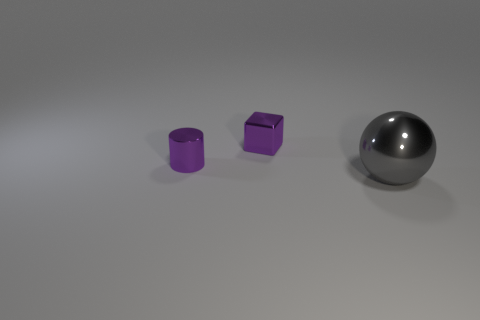Are there any large gray spheres made of the same material as the gray thing?
Your answer should be very brief. No. There is a purple thing that is the same size as the purple cube; what is its material?
Provide a succinct answer. Metal. There is a tiny metal thing in front of the cube; does it have the same color as the shiny object right of the purple shiny block?
Provide a short and direct response. No. There is a purple metallic object in front of the metal block; is there a tiny purple metal thing to the left of it?
Your answer should be compact. No. Does the object that is to the left of the shiny cube have the same shape as the tiny object that is behind the purple metal cylinder?
Your response must be concise. No. Do the small object in front of the small purple cube and the sphere that is in front of the purple shiny block have the same material?
Your answer should be very brief. Yes. The small purple object right of the purple thing in front of the cube is made of what material?
Provide a succinct answer. Metal. There is a metallic object to the right of the small shiny object behind the purple metal object that is on the left side of the metallic cube; what is its shape?
Keep it short and to the point. Sphere. What number of green matte balls are there?
Give a very brief answer. 0. What is the shape of the shiny thing that is on the left side of the cube?
Your response must be concise. Cylinder. 